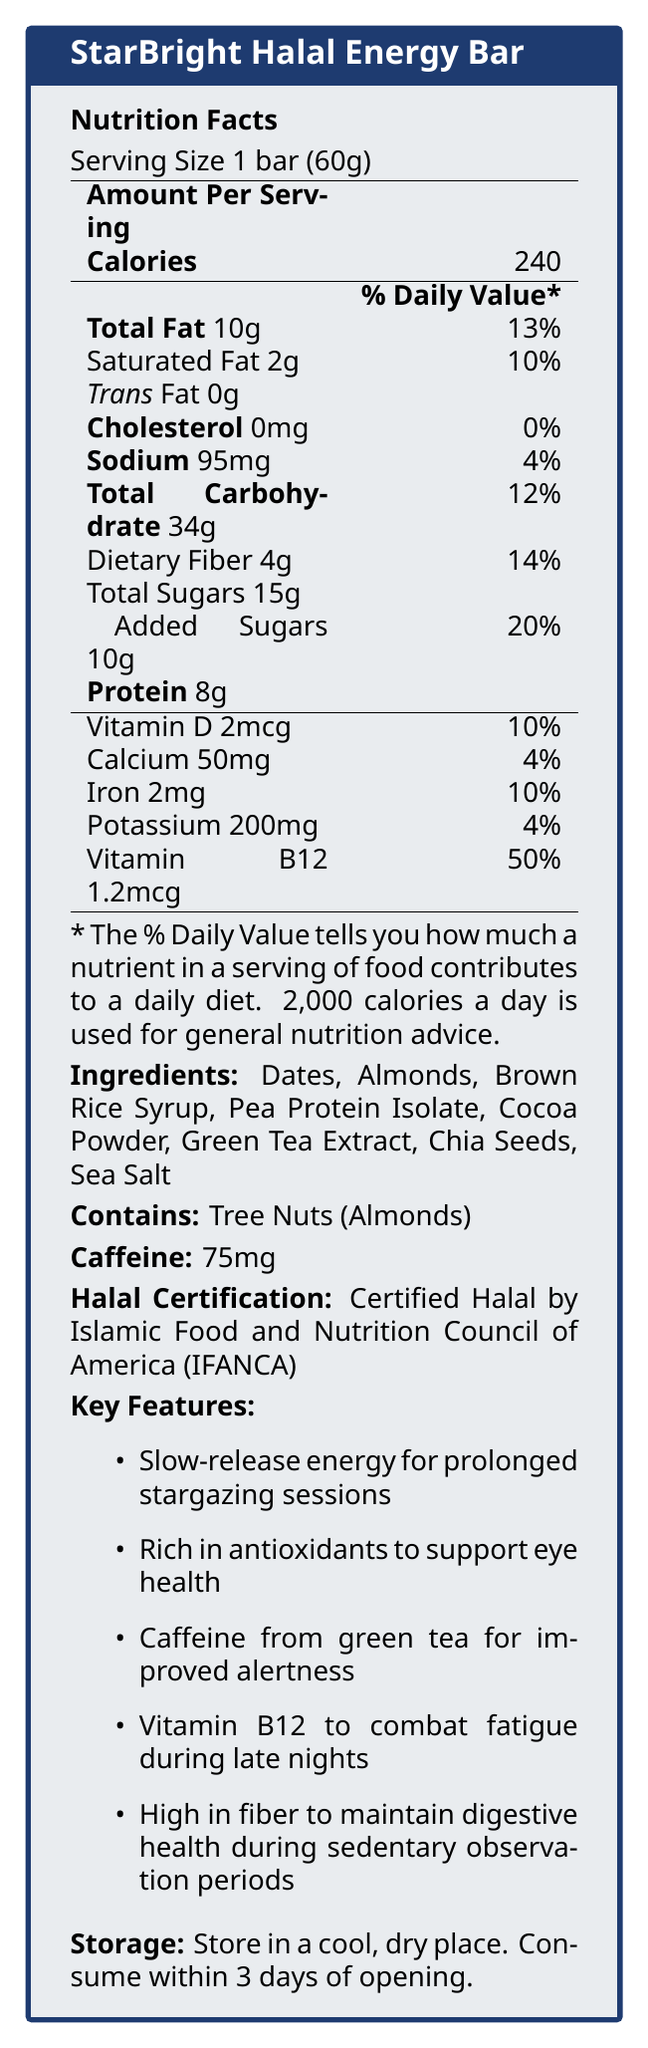who certifies the halal certification of the StarBright Halal Energy Bar? The document states that the halal certification is provided by IFANCA.
Answer: Islamic Food and Nutrition Council of America (IFANCA) how much protein does one serving of the StarBright Halal Energy Bar contain? According to the nutrition facts, one bar (serving size) contains 8g of protein.
Answer: 8g how much dietary fiber is in one StarBright Halal Energy Bar? The nutrition facts label specifies that there are 4g of dietary fiber per serving.
Answer: 4g how many calories are in one serving of the StarBright Halal Energy Bar? The nutrition facts label clearly states that one serving contains 240 calories.
Answer: 240 what ingredients are used in the StarBright Halal Energy Bar? The document lists these ingredients in the ingredient section.
Answer: Dates, Almonds, Brown Rice Syrup, Pea Protein Isolate, Cocoa Powder, Green Tea Extract, Chia Seeds, Sea Salt what is the serving size of the StarBright Halal Energy Bar? The top of the nutrition facts label specifies the serving size as 1 bar (60g).
Answer: 1 bar (60g) what is the main source of caffeine in the StarBright Halal Energy Bar? The key features section mentions caffeine from green tea as an ingredient for improved alertness.
Answer: Green Tea Extract What percentage of the daily value for Vitamin B12 does one StarBright Halal Energy Bar provide? A. 10% B. 20% C. 50% D. 100% The nutrition facts specify that one bar provides 50% of the daily value for Vitamin B12.
Answer: C. 50% How many grams of total fat does one StarBright Halal Energy Bar contain? A. 5g B. 10g C. 15g D. 20g The nutrition facts label states that there are 10g of total fat per serving.
Answer: B. 10g Does the StarBright Halal Energy Bar contain any allergens? The document mentions that the bar contains tree nuts (almonds).
Answer: Yes describe the main idea of the document The document aims to inform consumers about the nutritional content and benefits of the StarBright Halal Energy Bar, which is specifically designed to provide sustained energy and support various health aspects during prolonged stargazing sessions.
Answer: The document provides a detailed nutrition facts label for the StarBright Halal Energy Bar, designed for late-night stargazing sessions. It includes information on serving size, calories, macronutrients, vitamins, minerals, caffeine content, ingredients, allergens, and key features like halal certification and storage instructions. What is the price of one StarBright Halal Energy Bar? The document does not provide any information regarding the price of the bar.
Answer: Cannot be determined 